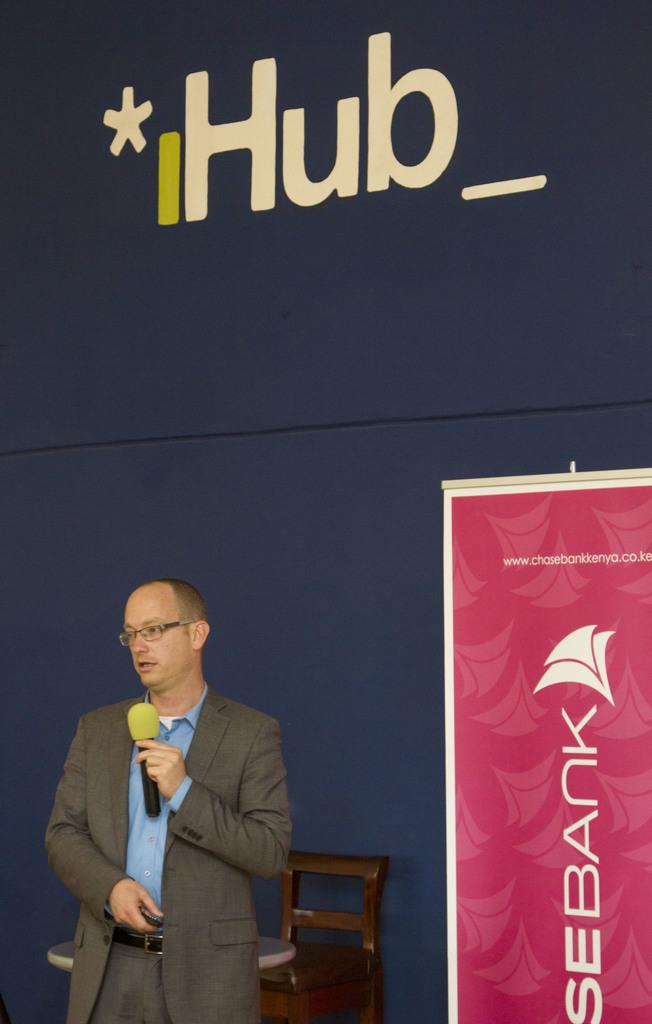Who is the main subject in the image? There is a man in the image. What is the man holding in his hand? The man is holding a mic in his hand. What can be seen in the background of the image? There is a banner in the background of the image. What type of furniture is present in the image? There is a chair and a table in the image. What type of adjustment is the governor making to the branch in the image? There is no governor or branch present in the image. 